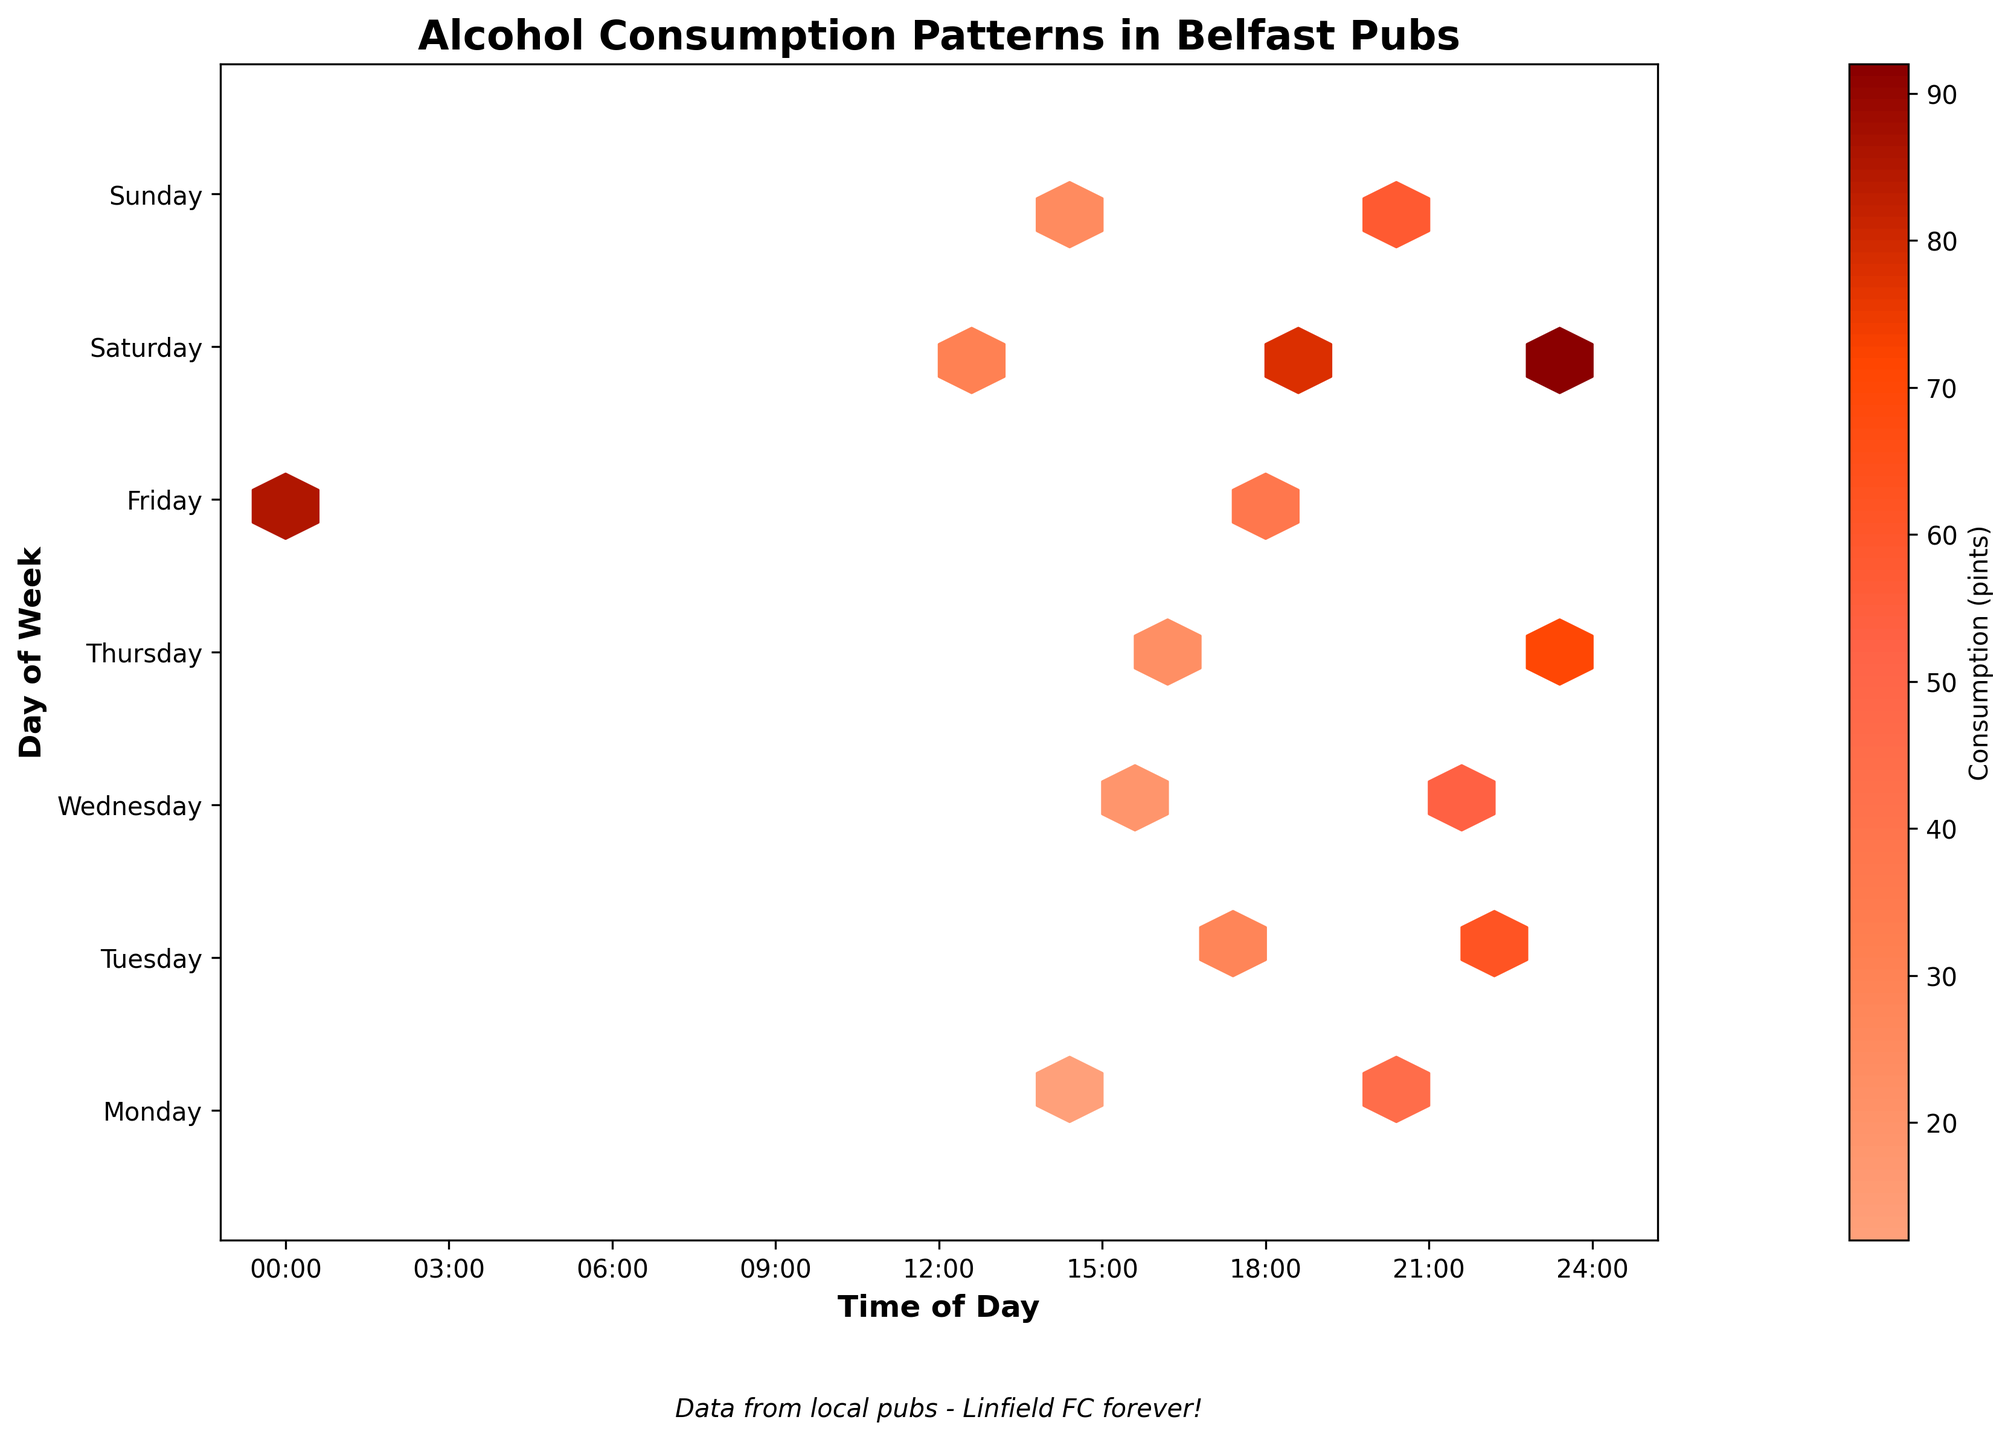What's the title of this plot? The title is usually at the top of the plot and provides a summary of the information being presented.
Answer: Alcohol Consumption Patterns in Belfast Pubs What is represented by the color bar? The color bar usually indicates the scale of consumption. Based on the figure, the color bar would range from lighter to darker colors representing the number of pints consumed.
Answer: Consumption (pints) Which days show the highest alcohol consumption? By looking at the hexbin plot, identify which rows (days) have the darkest hexagons, which represent the highest pints of consumption.
Answer: Friday and Saturday What time of day has the highest alcohol consumption on Saturday? Look for the darkest hexagons in the row corresponding to Saturday and identify the time on the x-axis where they appear.
Answer: 23:30 Are there any days where alcohol consumption is low in the mornings? Morning hours would range from 0:00 to around 12:00. Check for lighter hexagons or absence of hexagons in these time ranges across the days.
Answer: Yes, most mornings How does alcohol consumption on Monday at 20:00 compare to Thursday at 23:00? Find the color or intensity of hexagons corresponding to the specific day and time and compare them.
Answer: Monday at 20:00 is lower What general trend can you observe about alcohol consumption on weekends? Analyze the position and intensity of hexagons particularly on Saturday and Sunday compared to other days.
Answer: Higher consumption in the evenings What is the typical time range for peak alcohol consumption during the week? Look across the rows for the weekdays (Monday to Friday) and note the common times where the darkest hexagons appear.
Answer: Late evenings, around 20:00 to 23:00 Is there a significant difference in alcohol consumption between weekdays and weekends? Compare the intensity and frequency of hexagons between Monday to Friday and Saturday to Sunday.
Answer: Yes, weekends have higher consumption What can you infer about the variability of alcohol consumption throughout a single day? Look at the distribution of hexagons across a single row (one day) to see how consumption varies from morning to night.
Answer: Higher variability in the late evenings, especially on weekends 